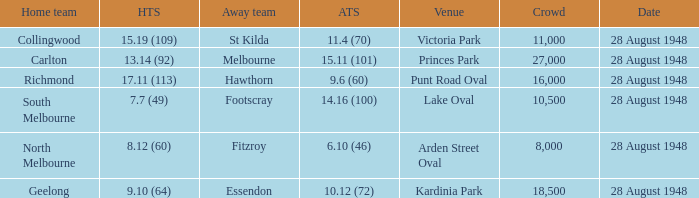What home team has a team score of 8.12 (60)? North Melbourne. 